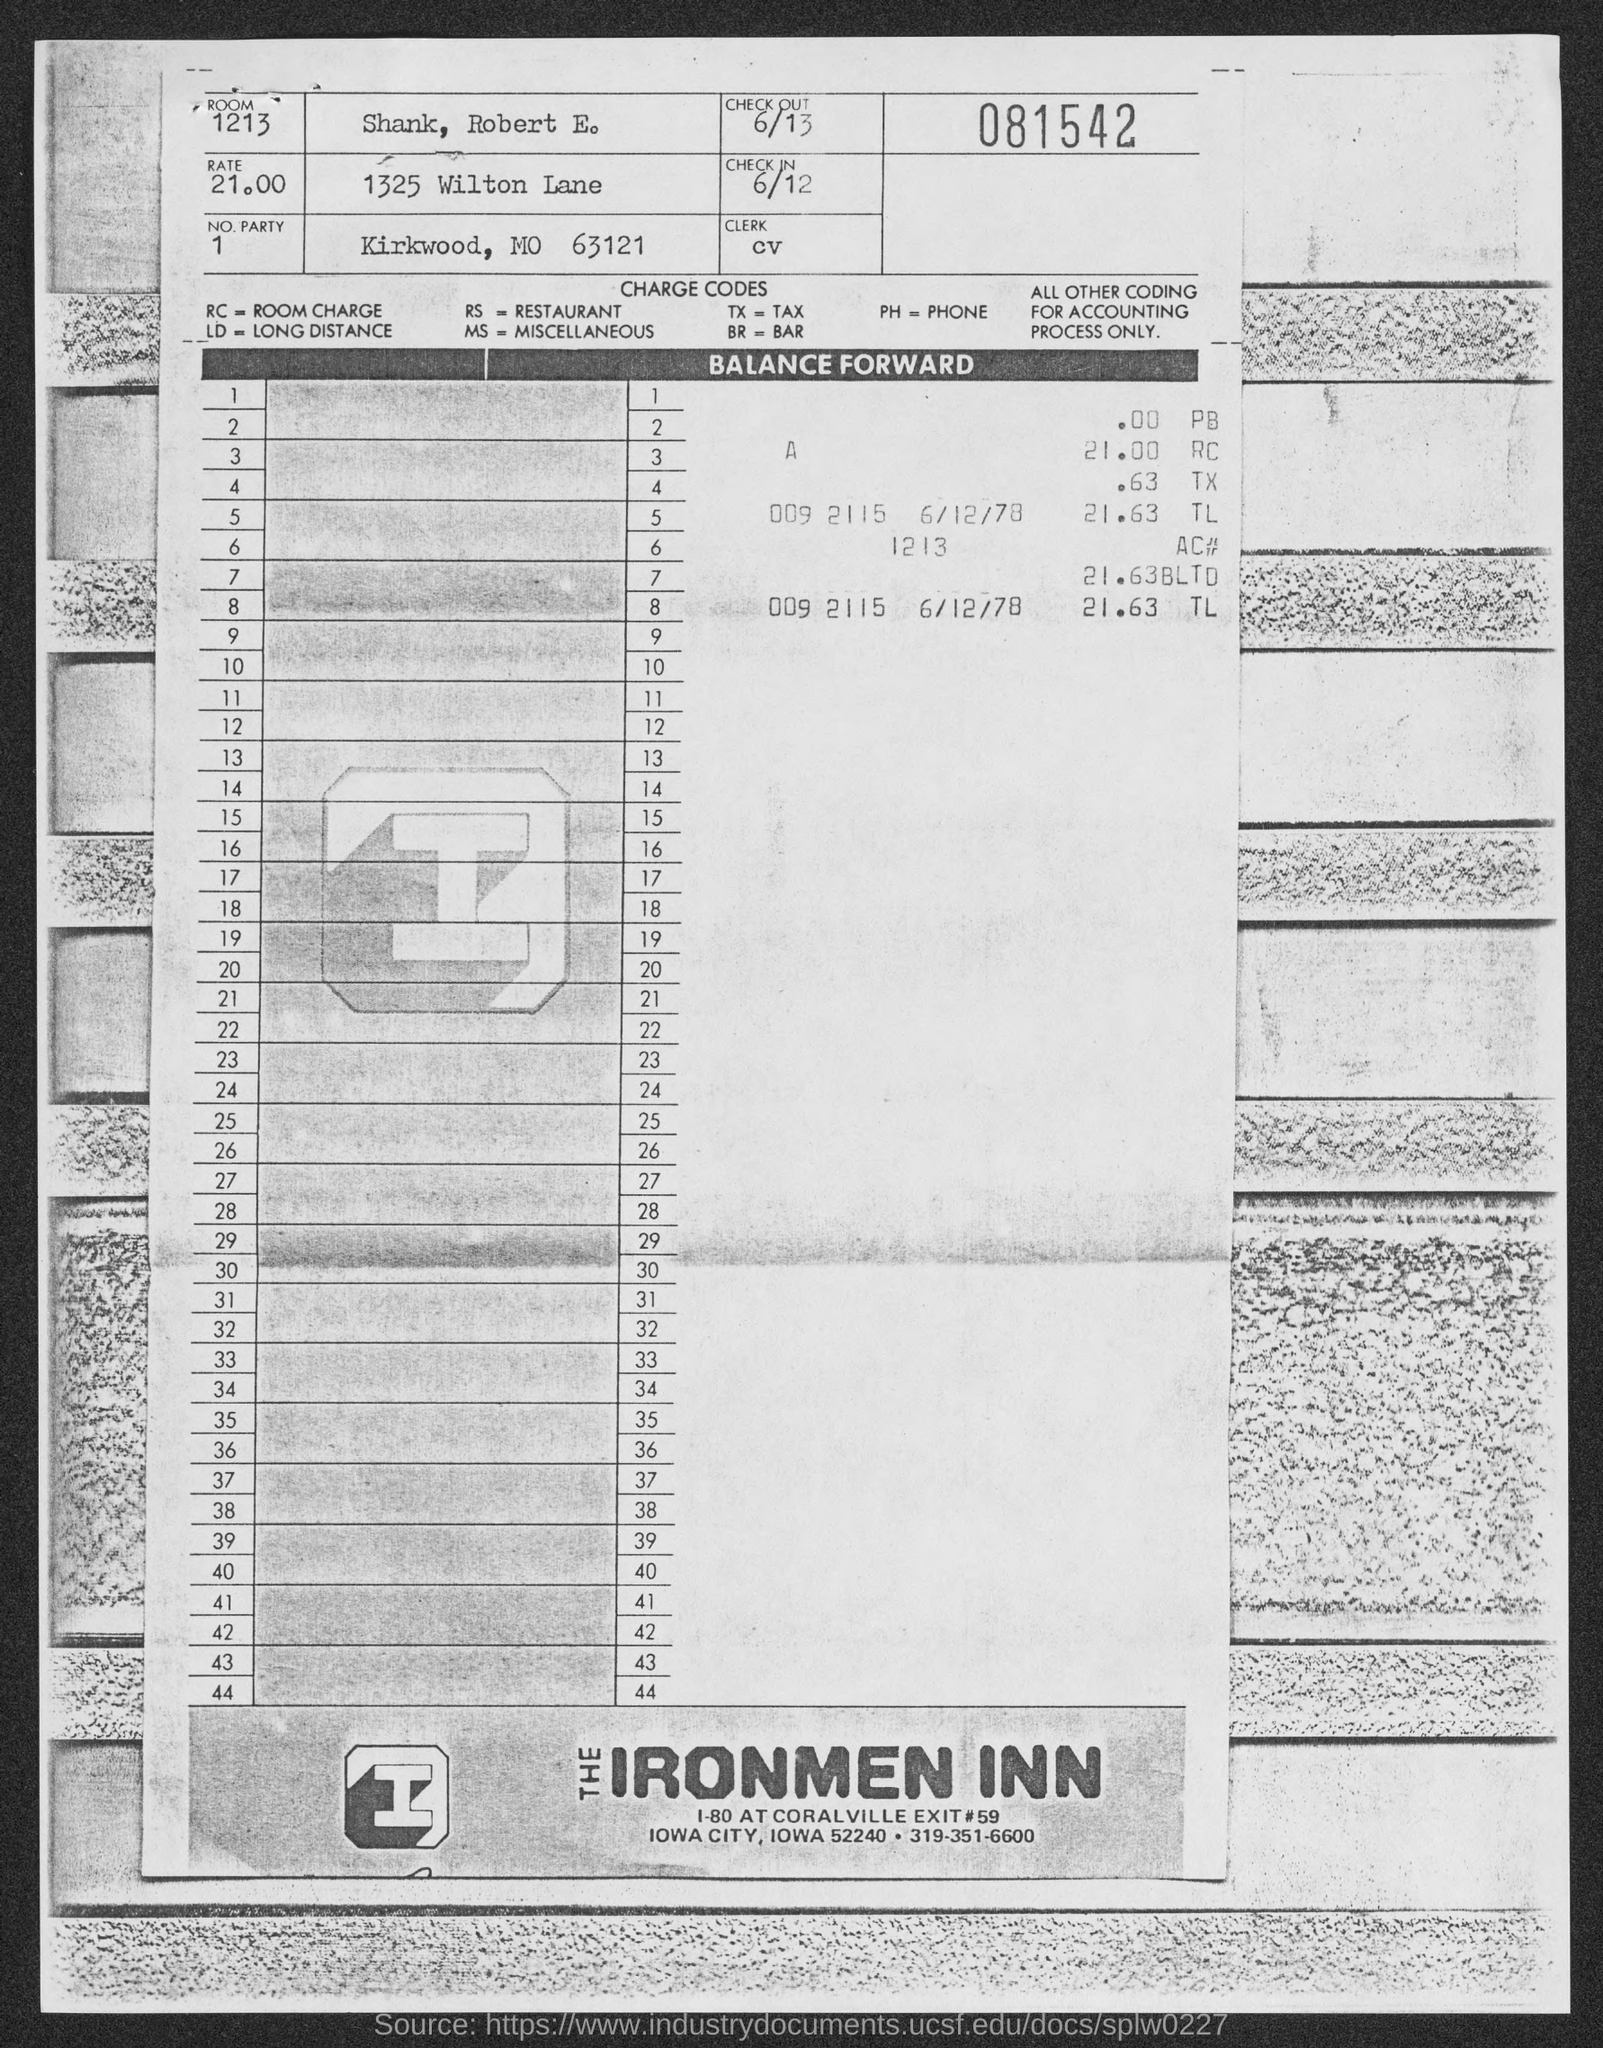Mention a couple of crucial points in this snapshot. What is the number party mentioned in the given page? The check-out date mentioned on the given page is June 13th. The charge code for RC, as mentioned on the given page, is Room Charge. The name of the person mentioned in the given page is Shank, Robert E. The room number mentioned in the given page is 1213. 